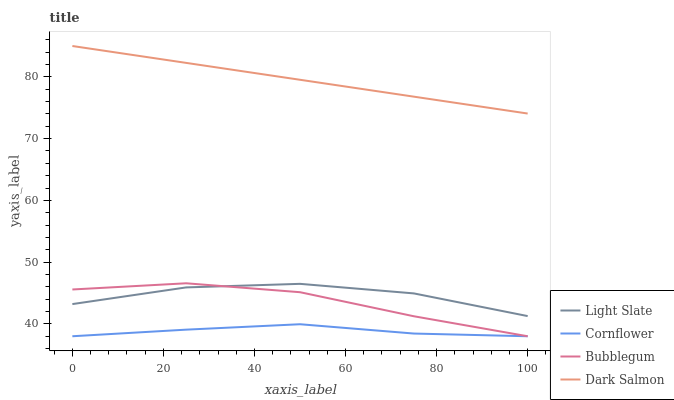Does Cornflower have the minimum area under the curve?
Answer yes or no. Yes. Does Dark Salmon have the maximum area under the curve?
Answer yes or no. Yes. Does Dark Salmon have the minimum area under the curve?
Answer yes or no. No. Does Cornflower have the maximum area under the curve?
Answer yes or no. No. Is Dark Salmon the smoothest?
Answer yes or no. Yes. Is Light Slate the roughest?
Answer yes or no. Yes. Is Cornflower the smoothest?
Answer yes or no. No. Is Cornflower the roughest?
Answer yes or no. No. Does Cornflower have the lowest value?
Answer yes or no. Yes. Does Dark Salmon have the lowest value?
Answer yes or no. No. Does Dark Salmon have the highest value?
Answer yes or no. Yes. Does Cornflower have the highest value?
Answer yes or no. No. Is Cornflower less than Dark Salmon?
Answer yes or no. Yes. Is Dark Salmon greater than Bubblegum?
Answer yes or no. Yes. Does Bubblegum intersect Light Slate?
Answer yes or no. Yes. Is Bubblegum less than Light Slate?
Answer yes or no. No. Is Bubblegum greater than Light Slate?
Answer yes or no. No. Does Cornflower intersect Dark Salmon?
Answer yes or no. No. 